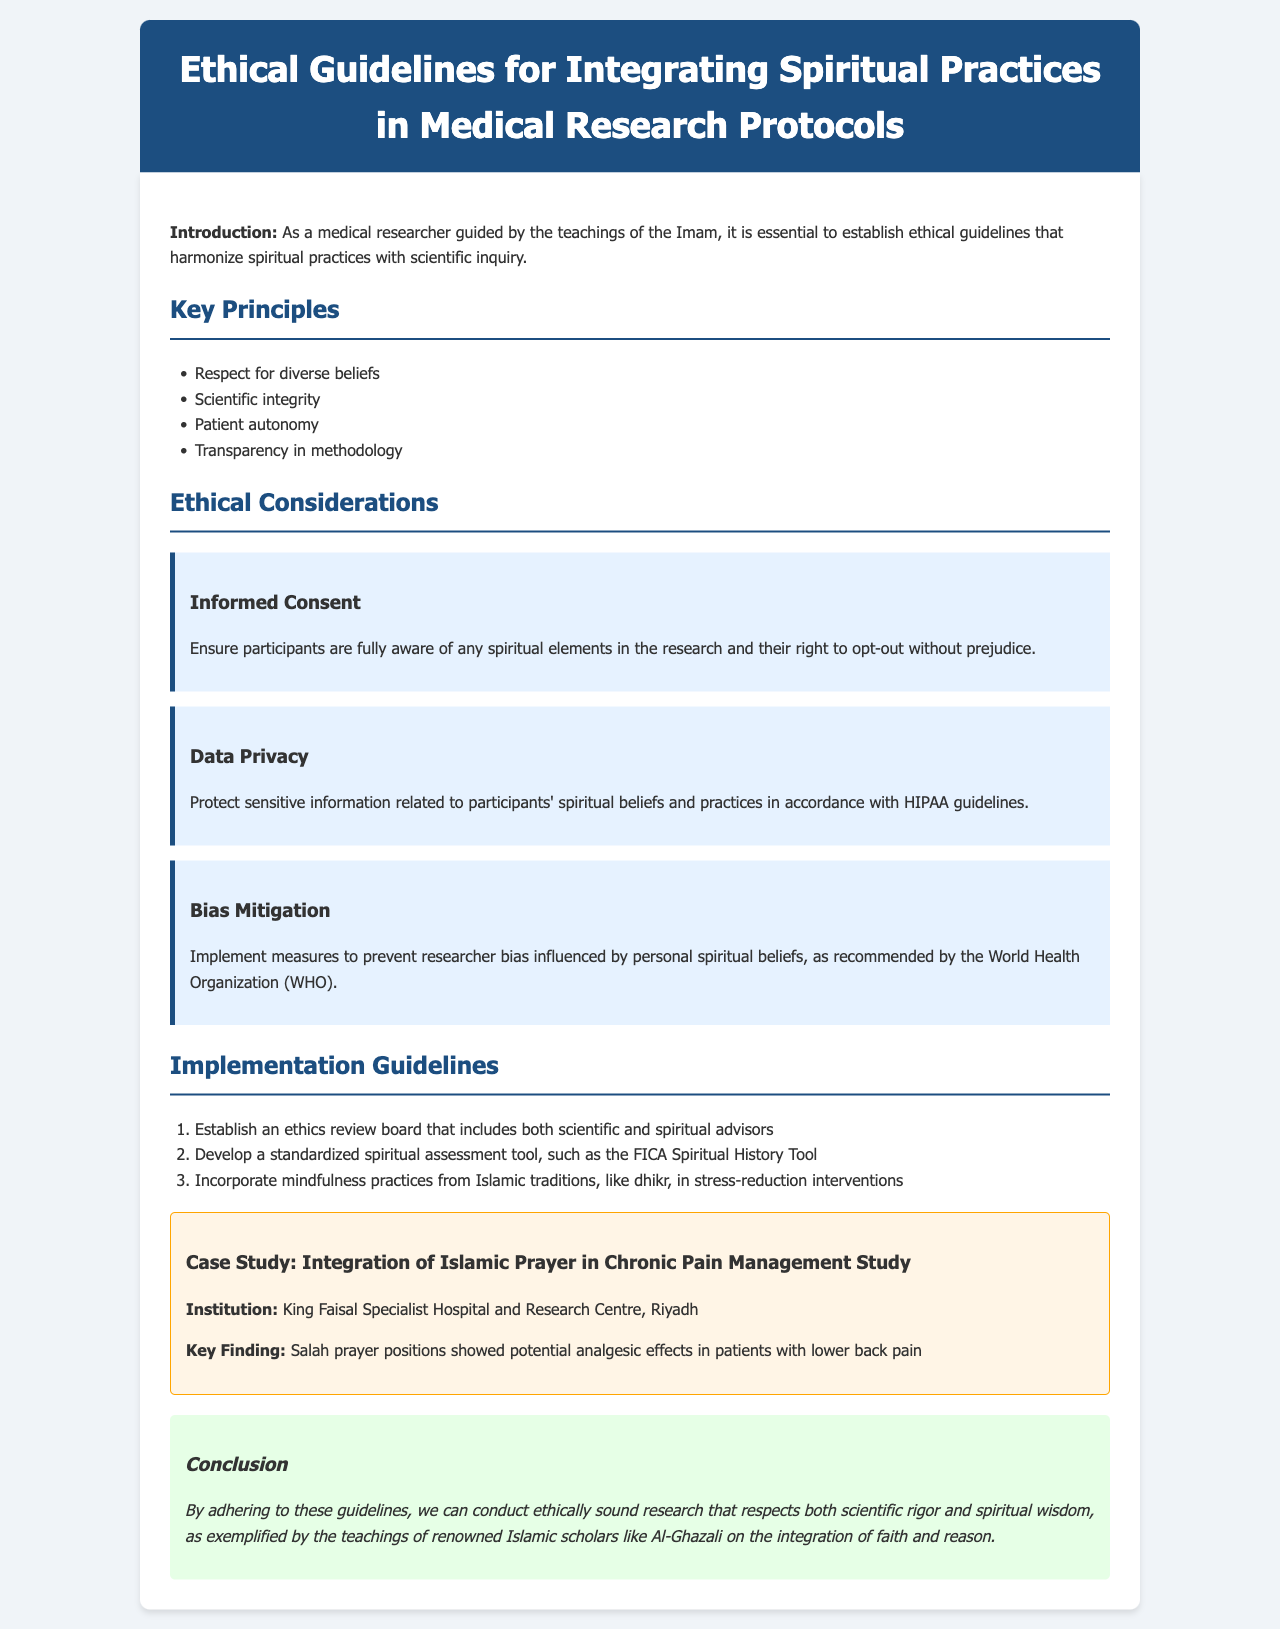what is the title of the document? The title of the document is mentioned in the header section as "Ethical Guidelines for Integrating Spiritual Practices in Medical Research Protocols."
Answer: Ethical Guidelines for Integrating Spiritual Practices in Medical Research Protocols what is one key principle mentioned in the document? A key principle is listed under the "Key Principles" section. One example is "Respect for diverse beliefs."
Answer: Respect for diverse beliefs what does informed consent ensure? The document states that informed consent is to ensure participants are fully aware of any spiritual elements in the research.
Answer: Participants are fully aware of any spiritual elements how many ethical considerations are detailed in the document? The document provides information about three ethical considerations in the relevant section.
Answer: Three which institution conducted the case study on Islamic prayer in chronic pain management? The case study provides the name of the institution in the "Case Study" section as "King Faisal Specialist Hospital and Research Centre, Riyadh."
Answer: King Faisal Specialist Hospital and Research Centre, Riyadh what is one implementation guideline listed? The "Implementation Guidelines" section outlines several guidelines, one being "Establish an ethics review board that includes both scientific and spiritual advisors."
Answer: Establish an ethics review board that includes both scientific and spiritual advisors who is a referenced scholar regarding faith and reason integration? The document mentions Islamic scholars, specifically named Al-Ghazali in the conclusion.
Answer: Al-Ghazali what kind of practices are suggested to be incorporated into interventions? The document mentions the incorporation of "mindfulness practices from Islamic traditions" as one of the interventions.
Answer: Mindfulness practices from Islamic traditions 